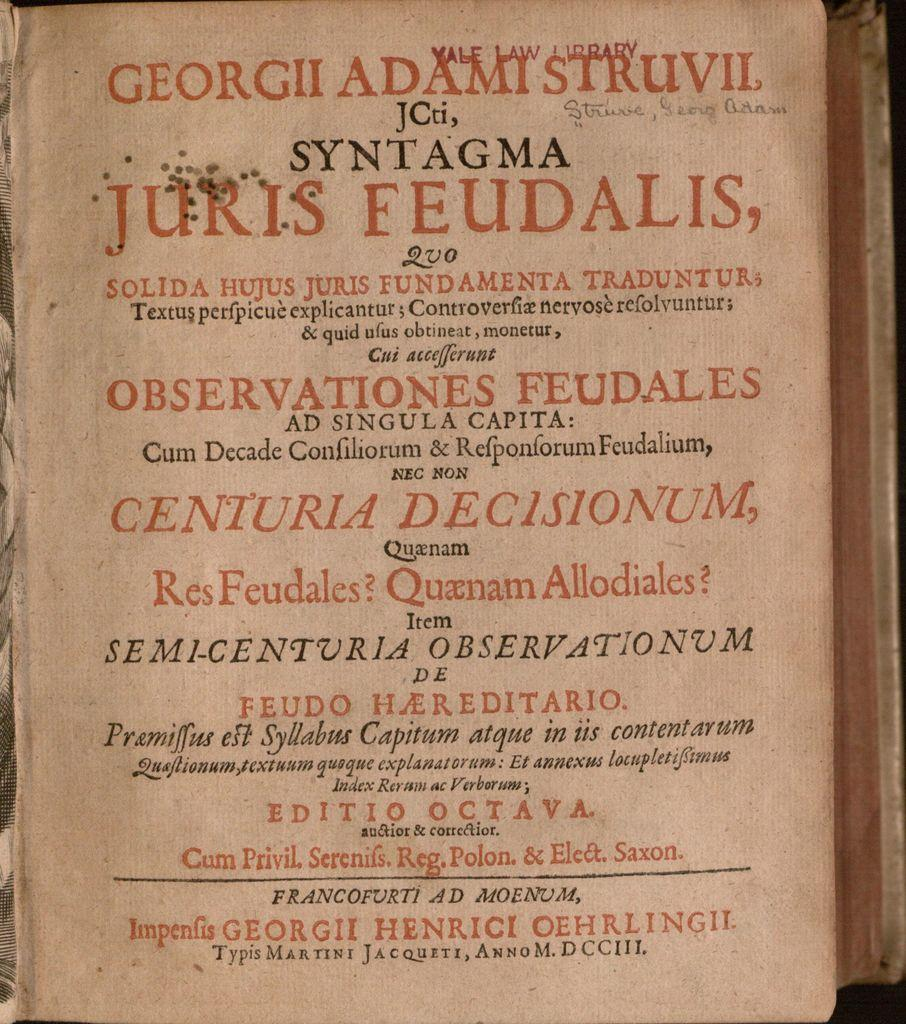Provide a one-sentence caption for the provided image. old book with YALE LAW LIBRARY stamped in red at top. 